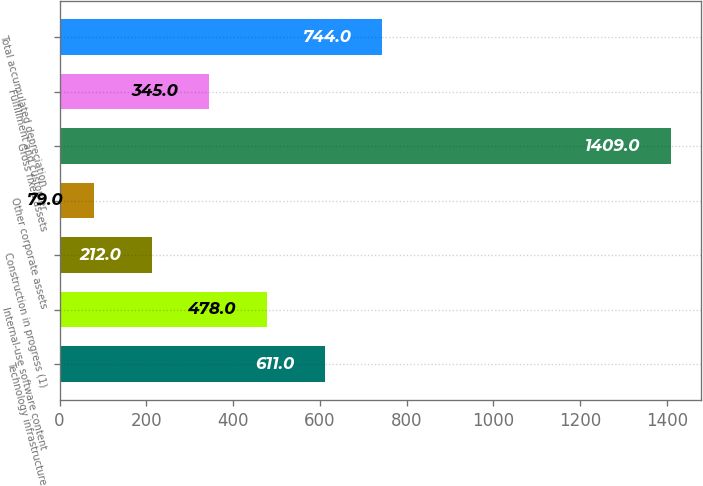Convert chart. <chart><loc_0><loc_0><loc_500><loc_500><bar_chart><fcel>Technology infrastructure<fcel>Internal-use software content<fcel>Construction in progress (1)<fcel>Other corporate assets<fcel>Gross fixed assets<fcel>Fulfillment and customer<fcel>Total accumulated depreciation<nl><fcel>611<fcel>478<fcel>212<fcel>79<fcel>1409<fcel>345<fcel>744<nl></chart> 